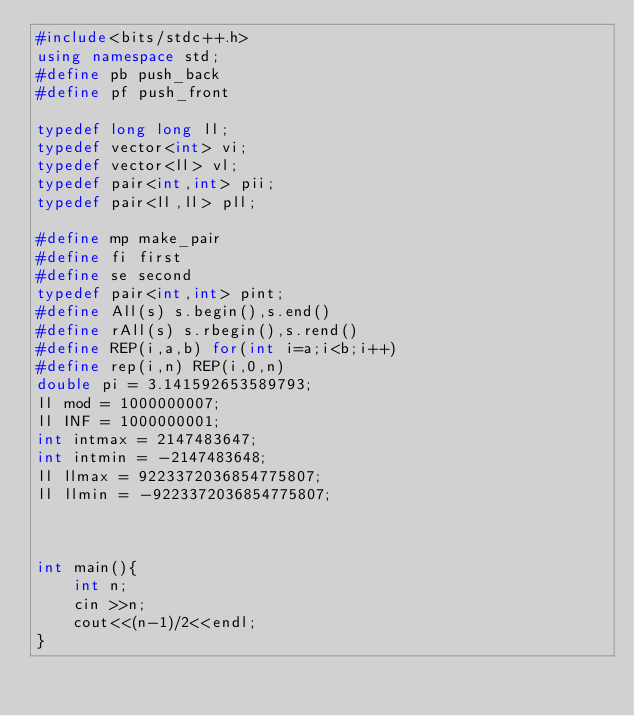Convert code to text. <code><loc_0><loc_0><loc_500><loc_500><_C++_>#include<bits/stdc++.h>
using namespace std;
#define pb push_back
#define pf push_front

typedef long long ll;
typedef vector<int> vi;
typedef vector<ll> vl;
typedef pair<int,int> pii;
typedef pair<ll,ll> pll;

#define mp make_pair
#define fi first
#define se second
typedef pair<int,int> pint;
#define All(s) s.begin(),s.end()
#define rAll(s) s.rbegin(),s.rend()
#define REP(i,a,b) for(int i=a;i<b;i++)
#define rep(i,n) REP(i,0,n)
double pi = 3.141592653589793;
ll mod = 1000000007;
ll INF = 1000000001;
int intmax = 2147483647;
int intmin = -2147483648;
ll llmax = 9223372036854775807;
ll llmin = -9223372036854775807;



int main(){
    int n;
    cin >>n;
    cout<<(n-1)/2<<endl;
}
</code> 